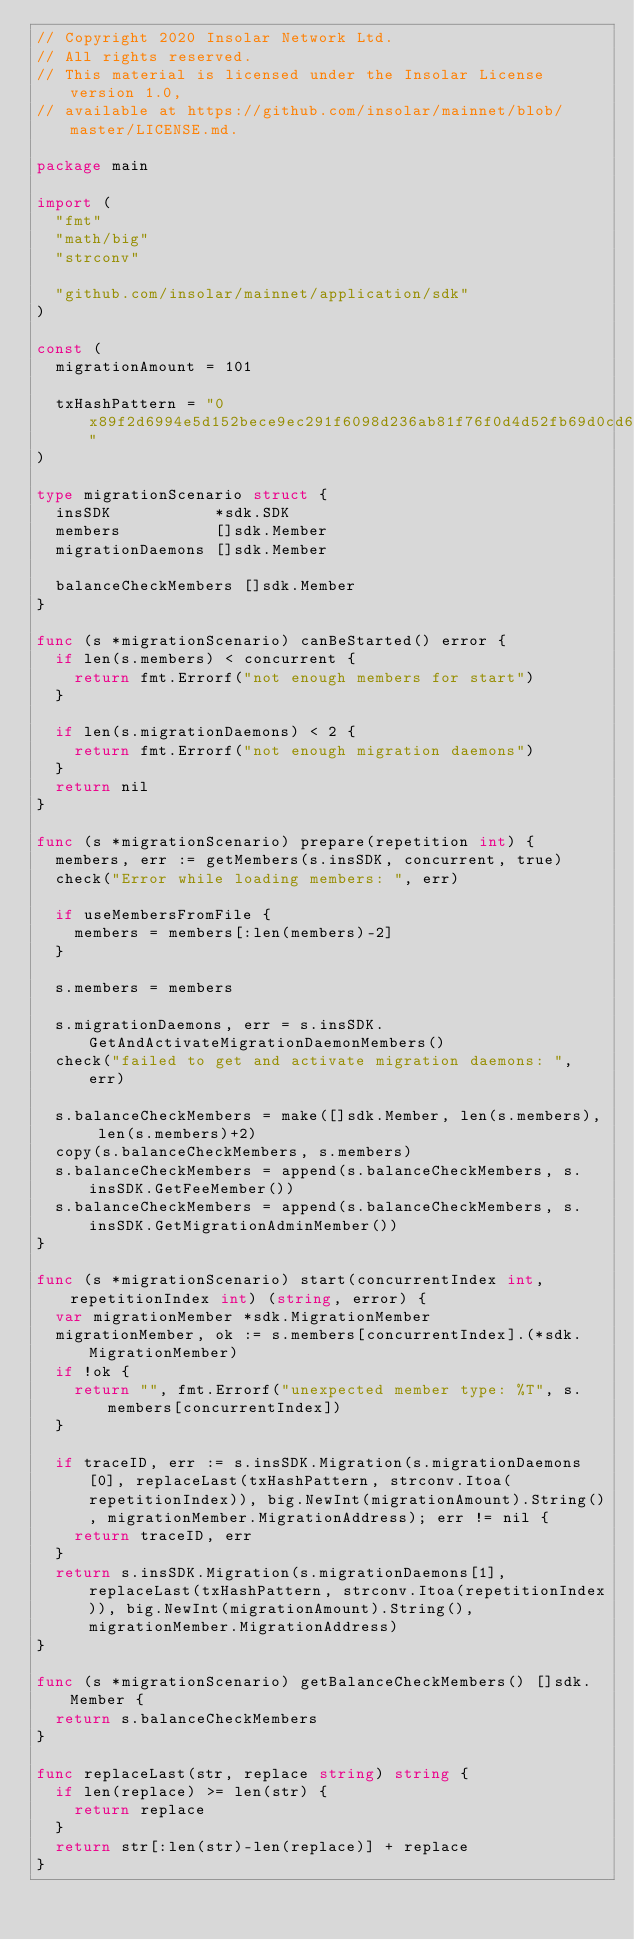Convert code to text. <code><loc_0><loc_0><loc_500><loc_500><_Go_>// Copyright 2020 Insolar Network Ltd.
// All rights reserved.
// This material is licensed under the Insolar License version 1.0,
// available at https://github.com/insolar/mainnet/blob/master/LICENSE.md.

package main

import (
	"fmt"
	"math/big"
	"strconv"

	"github.com/insolar/mainnet/application/sdk"
)

const (
	migrationAmount = 101

	txHashPattern = "0x89f2d6994e5d152bece9ec291f6098d236ab81f76f0d4d52fb69d0cd6b6fd70d"
)

type migrationScenario struct {
	insSDK           *sdk.SDK
	members          []sdk.Member
	migrationDaemons []sdk.Member

	balanceCheckMembers []sdk.Member
}

func (s *migrationScenario) canBeStarted() error {
	if len(s.members) < concurrent {
		return fmt.Errorf("not enough members for start")
	}

	if len(s.migrationDaemons) < 2 {
		return fmt.Errorf("not enough migration daemons")
	}
	return nil
}

func (s *migrationScenario) prepare(repetition int) {
	members, err := getMembers(s.insSDK, concurrent, true)
	check("Error while loading members: ", err)

	if useMembersFromFile {
		members = members[:len(members)-2]
	}

	s.members = members

	s.migrationDaemons, err = s.insSDK.GetAndActivateMigrationDaemonMembers()
	check("failed to get and activate migration daemons: ", err)

	s.balanceCheckMembers = make([]sdk.Member, len(s.members), len(s.members)+2)
	copy(s.balanceCheckMembers, s.members)
	s.balanceCheckMembers = append(s.balanceCheckMembers, s.insSDK.GetFeeMember())
	s.balanceCheckMembers = append(s.balanceCheckMembers, s.insSDK.GetMigrationAdminMember())
}

func (s *migrationScenario) start(concurrentIndex int, repetitionIndex int) (string, error) {
	var migrationMember *sdk.MigrationMember
	migrationMember, ok := s.members[concurrentIndex].(*sdk.MigrationMember)
	if !ok {
		return "", fmt.Errorf("unexpected member type: %T", s.members[concurrentIndex])
	}

	if traceID, err := s.insSDK.Migration(s.migrationDaemons[0], replaceLast(txHashPattern, strconv.Itoa(repetitionIndex)), big.NewInt(migrationAmount).String(), migrationMember.MigrationAddress); err != nil {
		return traceID, err
	}
	return s.insSDK.Migration(s.migrationDaemons[1], replaceLast(txHashPattern, strconv.Itoa(repetitionIndex)), big.NewInt(migrationAmount).String(), migrationMember.MigrationAddress)
}

func (s *migrationScenario) getBalanceCheckMembers() []sdk.Member {
	return s.balanceCheckMembers
}

func replaceLast(str, replace string) string {
	if len(replace) >= len(str) {
		return replace
	}
	return str[:len(str)-len(replace)] + replace
}
</code> 